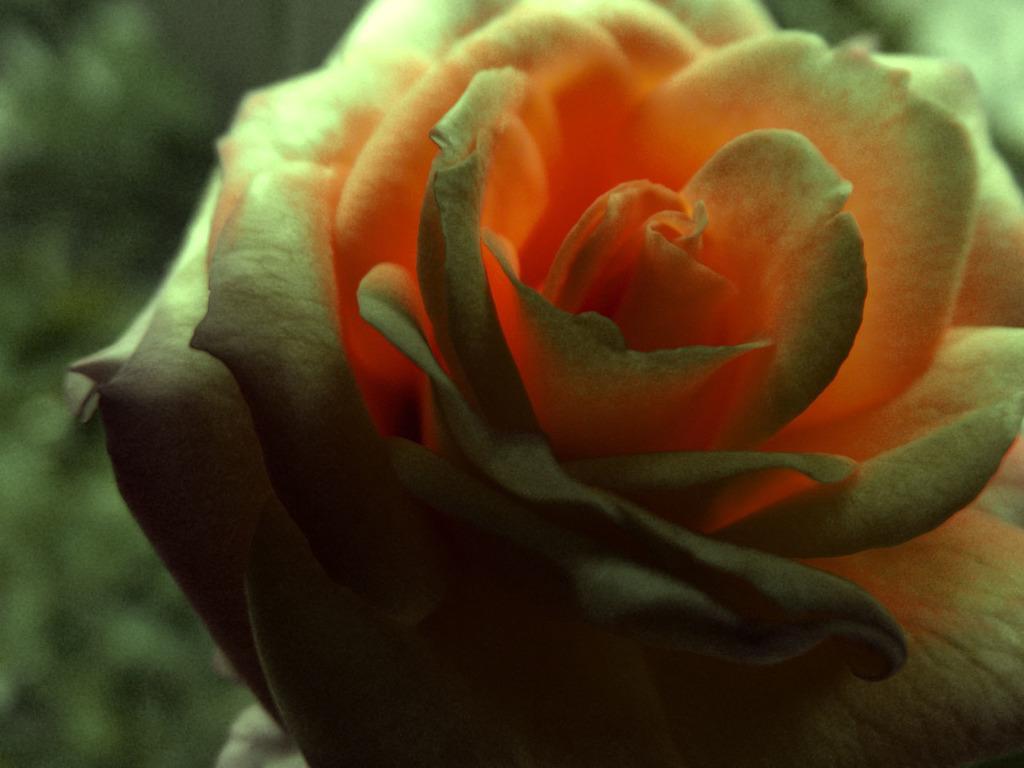Please provide a concise description of this image. In the picture there is a beautiful cream and orange color rose. 